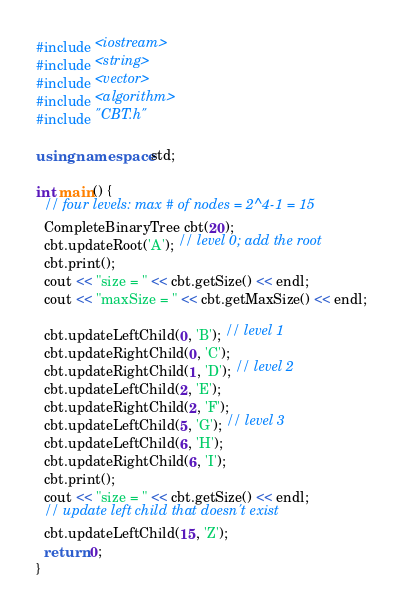<code> <loc_0><loc_0><loc_500><loc_500><_C++_>#include <iostream>
#include <string>
#include <vector>
#include <algorithm>
#include "CBT.h"

using namespace std;

int main() {
  // four levels: max # of nodes = 2^4-1 = 15
  CompleteBinaryTree cbt(20);
  cbt.updateRoot('A'); // level 0; add the root
  cbt.print();
  cout << "size = " << cbt.getSize() << endl;
  cout << "maxSize = " << cbt.getMaxSize() << endl;

  cbt.updateLeftChild(0, 'B'); // level 1
  cbt.updateRightChild(0, 'C');
  cbt.updateRightChild(1, 'D'); // level 2
  cbt.updateLeftChild(2, 'E');
  cbt.updateRightChild(2, 'F');
  cbt.updateLeftChild(5, 'G'); // level 3
  cbt.updateLeftChild(6, 'H');
  cbt.updateRightChild(6, 'I');
  cbt.print();
  cout << "size = " << cbt.getSize() << endl;
  // update left child that doesn't exist
  cbt.updateLeftChild(15, 'Z');
  return 0;
}</code> 